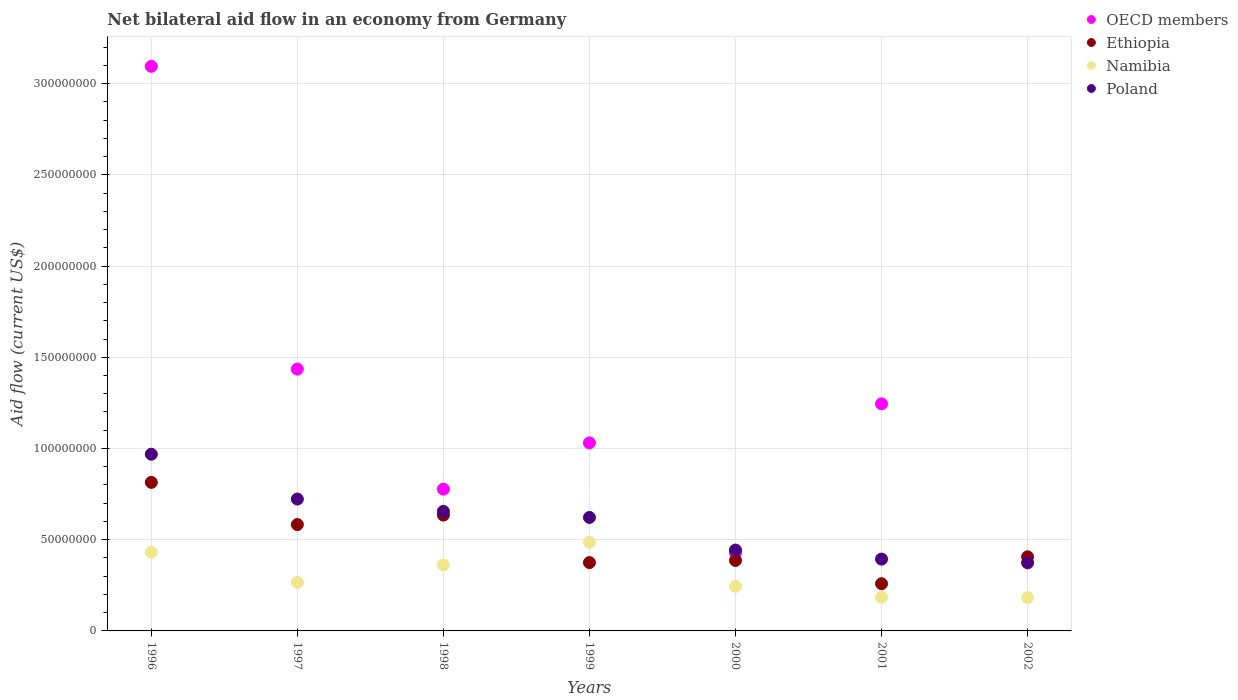What is the net bilateral aid flow in OECD members in 1998?
Your answer should be very brief. 7.77e+07. Across all years, what is the maximum net bilateral aid flow in Namibia?
Your answer should be compact. 4.85e+07. Across all years, what is the minimum net bilateral aid flow in Poland?
Keep it short and to the point. 3.73e+07. What is the total net bilateral aid flow in Ethiopia in the graph?
Provide a short and direct response. 3.46e+08. What is the difference between the net bilateral aid flow in Poland in 1998 and that in 1999?
Keep it short and to the point. 3.34e+06. What is the difference between the net bilateral aid flow in Ethiopia in 1998 and the net bilateral aid flow in Namibia in 1997?
Provide a short and direct response. 3.69e+07. What is the average net bilateral aid flow in Namibia per year?
Give a very brief answer. 3.08e+07. In the year 1999, what is the difference between the net bilateral aid flow in Poland and net bilateral aid flow in Namibia?
Your response must be concise. 1.37e+07. In how many years, is the net bilateral aid flow in OECD members greater than 230000000 US$?
Ensure brevity in your answer.  1. What is the ratio of the net bilateral aid flow in Ethiopia in 1998 to that in 1999?
Give a very brief answer. 1.69. Is the net bilateral aid flow in OECD members in 2000 less than that in 2001?
Make the answer very short. Yes. Is the difference between the net bilateral aid flow in Poland in 2000 and 2001 greater than the difference between the net bilateral aid flow in Namibia in 2000 and 2001?
Make the answer very short. No. What is the difference between the highest and the second highest net bilateral aid flow in Poland?
Offer a very short reply. 2.46e+07. What is the difference between the highest and the lowest net bilateral aid flow in OECD members?
Your response must be concise. 3.09e+08. In how many years, is the net bilateral aid flow in Poland greater than the average net bilateral aid flow in Poland taken over all years?
Keep it short and to the point. 4. Is the sum of the net bilateral aid flow in Namibia in 1999 and 2000 greater than the maximum net bilateral aid flow in Poland across all years?
Your answer should be very brief. No. Is it the case that in every year, the sum of the net bilateral aid flow in Ethiopia and net bilateral aid flow in OECD members  is greater than the net bilateral aid flow in Poland?
Ensure brevity in your answer.  Yes. Does the net bilateral aid flow in Ethiopia monotonically increase over the years?
Offer a very short reply. No. Is the net bilateral aid flow in OECD members strictly greater than the net bilateral aid flow in Poland over the years?
Your answer should be compact. No. How many years are there in the graph?
Offer a terse response. 7. Where does the legend appear in the graph?
Your answer should be very brief. Top right. How many legend labels are there?
Offer a terse response. 4. How are the legend labels stacked?
Your answer should be very brief. Vertical. What is the title of the graph?
Offer a terse response. Net bilateral aid flow in an economy from Germany. What is the label or title of the X-axis?
Your response must be concise. Years. What is the label or title of the Y-axis?
Offer a terse response. Aid flow (current US$). What is the Aid flow (current US$) in OECD members in 1996?
Your response must be concise. 3.09e+08. What is the Aid flow (current US$) of Ethiopia in 1996?
Provide a succinct answer. 8.14e+07. What is the Aid flow (current US$) of Namibia in 1996?
Provide a succinct answer. 4.31e+07. What is the Aid flow (current US$) in Poland in 1996?
Your response must be concise. 9.69e+07. What is the Aid flow (current US$) in OECD members in 1997?
Offer a very short reply. 1.44e+08. What is the Aid flow (current US$) of Ethiopia in 1997?
Offer a terse response. 5.83e+07. What is the Aid flow (current US$) in Namibia in 1997?
Offer a terse response. 2.66e+07. What is the Aid flow (current US$) in Poland in 1997?
Offer a very short reply. 7.23e+07. What is the Aid flow (current US$) of OECD members in 1998?
Offer a terse response. 7.77e+07. What is the Aid flow (current US$) of Ethiopia in 1998?
Keep it short and to the point. 6.35e+07. What is the Aid flow (current US$) in Namibia in 1998?
Offer a very short reply. 3.61e+07. What is the Aid flow (current US$) of Poland in 1998?
Your response must be concise. 6.55e+07. What is the Aid flow (current US$) in OECD members in 1999?
Provide a succinct answer. 1.03e+08. What is the Aid flow (current US$) of Ethiopia in 1999?
Keep it short and to the point. 3.75e+07. What is the Aid flow (current US$) of Namibia in 1999?
Offer a very short reply. 4.85e+07. What is the Aid flow (current US$) in Poland in 1999?
Your answer should be very brief. 6.22e+07. What is the Aid flow (current US$) in OECD members in 2000?
Offer a terse response. 4.28e+07. What is the Aid flow (current US$) in Ethiopia in 2000?
Offer a very short reply. 3.86e+07. What is the Aid flow (current US$) in Namibia in 2000?
Give a very brief answer. 2.44e+07. What is the Aid flow (current US$) in Poland in 2000?
Offer a terse response. 4.43e+07. What is the Aid flow (current US$) of OECD members in 2001?
Give a very brief answer. 1.24e+08. What is the Aid flow (current US$) of Ethiopia in 2001?
Your answer should be compact. 2.59e+07. What is the Aid flow (current US$) in Namibia in 2001?
Your answer should be very brief. 1.84e+07. What is the Aid flow (current US$) of Poland in 2001?
Offer a very short reply. 3.94e+07. What is the Aid flow (current US$) of Ethiopia in 2002?
Your response must be concise. 4.06e+07. What is the Aid flow (current US$) in Namibia in 2002?
Your answer should be compact. 1.83e+07. What is the Aid flow (current US$) in Poland in 2002?
Offer a very short reply. 3.73e+07. Across all years, what is the maximum Aid flow (current US$) of OECD members?
Provide a short and direct response. 3.09e+08. Across all years, what is the maximum Aid flow (current US$) in Ethiopia?
Provide a short and direct response. 8.14e+07. Across all years, what is the maximum Aid flow (current US$) in Namibia?
Your answer should be compact. 4.85e+07. Across all years, what is the maximum Aid flow (current US$) of Poland?
Your response must be concise. 9.69e+07. Across all years, what is the minimum Aid flow (current US$) of Ethiopia?
Your answer should be compact. 2.59e+07. Across all years, what is the minimum Aid flow (current US$) in Namibia?
Keep it short and to the point. 1.83e+07. Across all years, what is the minimum Aid flow (current US$) in Poland?
Offer a terse response. 3.73e+07. What is the total Aid flow (current US$) in OECD members in the graph?
Your response must be concise. 8.01e+08. What is the total Aid flow (current US$) of Ethiopia in the graph?
Keep it short and to the point. 3.46e+08. What is the total Aid flow (current US$) in Namibia in the graph?
Give a very brief answer. 2.15e+08. What is the total Aid flow (current US$) in Poland in the graph?
Provide a short and direct response. 4.18e+08. What is the difference between the Aid flow (current US$) in OECD members in 1996 and that in 1997?
Your response must be concise. 1.66e+08. What is the difference between the Aid flow (current US$) of Ethiopia in 1996 and that in 1997?
Make the answer very short. 2.31e+07. What is the difference between the Aid flow (current US$) of Namibia in 1996 and that in 1997?
Provide a short and direct response. 1.66e+07. What is the difference between the Aid flow (current US$) in Poland in 1996 and that in 1997?
Ensure brevity in your answer.  2.46e+07. What is the difference between the Aid flow (current US$) of OECD members in 1996 and that in 1998?
Your response must be concise. 2.32e+08. What is the difference between the Aid flow (current US$) in Ethiopia in 1996 and that in 1998?
Ensure brevity in your answer.  1.79e+07. What is the difference between the Aid flow (current US$) of Namibia in 1996 and that in 1998?
Give a very brief answer. 6.99e+06. What is the difference between the Aid flow (current US$) in Poland in 1996 and that in 1998?
Give a very brief answer. 3.13e+07. What is the difference between the Aid flow (current US$) in OECD members in 1996 and that in 1999?
Provide a succinct answer. 2.06e+08. What is the difference between the Aid flow (current US$) in Ethiopia in 1996 and that in 1999?
Provide a short and direct response. 4.40e+07. What is the difference between the Aid flow (current US$) of Namibia in 1996 and that in 1999?
Provide a short and direct response. -5.41e+06. What is the difference between the Aid flow (current US$) of Poland in 1996 and that in 1999?
Keep it short and to the point. 3.47e+07. What is the difference between the Aid flow (current US$) of OECD members in 1996 and that in 2000?
Provide a short and direct response. 2.67e+08. What is the difference between the Aid flow (current US$) of Ethiopia in 1996 and that in 2000?
Offer a very short reply. 4.28e+07. What is the difference between the Aid flow (current US$) of Namibia in 1996 and that in 2000?
Keep it short and to the point. 1.87e+07. What is the difference between the Aid flow (current US$) of Poland in 1996 and that in 2000?
Give a very brief answer. 5.25e+07. What is the difference between the Aid flow (current US$) in OECD members in 1996 and that in 2001?
Provide a succinct answer. 1.85e+08. What is the difference between the Aid flow (current US$) in Ethiopia in 1996 and that in 2001?
Offer a very short reply. 5.56e+07. What is the difference between the Aid flow (current US$) in Namibia in 1996 and that in 2001?
Offer a terse response. 2.47e+07. What is the difference between the Aid flow (current US$) in Poland in 1996 and that in 2001?
Make the answer very short. 5.75e+07. What is the difference between the Aid flow (current US$) of Ethiopia in 1996 and that in 2002?
Provide a succinct answer. 4.08e+07. What is the difference between the Aid flow (current US$) in Namibia in 1996 and that in 2002?
Keep it short and to the point. 2.48e+07. What is the difference between the Aid flow (current US$) in Poland in 1996 and that in 2002?
Keep it short and to the point. 5.95e+07. What is the difference between the Aid flow (current US$) in OECD members in 1997 and that in 1998?
Offer a very short reply. 6.58e+07. What is the difference between the Aid flow (current US$) in Ethiopia in 1997 and that in 1998?
Your response must be concise. -5.19e+06. What is the difference between the Aid flow (current US$) in Namibia in 1997 and that in 1998?
Offer a terse response. -9.56e+06. What is the difference between the Aid flow (current US$) of Poland in 1997 and that in 1998?
Your answer should be compact. 6.74e+06. What is the difference between the Aid flow (current US$) of OECD members in 1997 and that in 1999?
Ensure brevity in your answer.  4.04e+07. What is the difference between the Aid flow (current US$) in Ethiopia in 1997 and that in 1999?
Provide a succinct answer. 2.08e+07. What is the difference between the Aid flow (current US$) of Namibia in 1997 and that in 1999?
Offer a terse response. -2.20e+07. What is the difference between the Aid flow (current US$) of Poland in 1997 and that in 1999?
Offer a terse response. 1.01e+07. What is the difference between the Aid flow (current US$) of OECD members in 1997 and that in 2000?
Make the answer very short. 1.01e+08. What is the difference between the Aid flow (current US$) of Ethiopia in 1997 and that in 2000?
Provide a succinct answer. 1.97e+07. What is the difference between the Aid flow (current US$) of Namibia in 1997 and that in 2000?
Your response must be concise. 2.12e+06. What is the difference between the Aid flow (current US$) in Poland in 1997 and that in 2000?
Your answer should be very brief. 2.80e+07. What is the difference between the Aid flow (current US$) of OECD members in 1997 and that in 2001?
Offer a terse response. 1.90e+07. What is the difference between the Aid flow (current US$) of Ethiopia in 1997 and that in 2001?
Provide a succinct answer. 3.24e+07. What is the difference between the Aid flow (current US$) of Namibia in 1997 and that in 2001?
Provide a succinct answer. 8.14e+06. What is the difference between the Aid flow (current US$) in Poland in 1997 and that in 2001?
Provide a short and direct response. 3.29e+07. What is the difference between the Aid flow (current US$) in Ethiopia in 1997 and that in 2002?
Ensure brevity in your answer.  1.77e+07. What is the difference between the Aid flow (current US$) in Namibia in 1997 and that in 2002?
Your answer should be very brief. 8.29e+06. What is the difference between the Aid flow (current US$) of Poland in 1997 and that in 2002?
Ensure brevity in your answer.  3.50e+07. What is the difference between the Aid flow (current US$) of OECD members in 1998 and that in 1999?
Ensure brevity in your answer.  -2.53e+07. What is the difference between the Aid flow (current US$) of Ethiopia in 1998 and that in 1999?
Provide a succinct answer. 2.60e+07. What is the difference between the Aid flow (current US$) in Namibia in 1998 and that in 1999?
Your answer should be very brief. -1.24e+07. What is the difference between the Aid flow (current US$) of Poland in 1998 and that in 1999?
Your answer should be very brief. 3.34e+06. What is the difference between the Aid flow (current US$) of OECD members in 1998 and that in 2000?
Your response must be concise. 3.49e+07. What is the difference between the Aid flow (current US$) of Ethiopia in 1998 and that in 2000?
Ensure brevity in your answer.  2.49e+07. What is the difference between the Aid flow (current US$) in Namibia in 1998 and that in 2000?
Your response must be concise. 1.17e+07. What is the difference between the Aid flow (current US$) in Poland in 1998 and that in 2000?
Offer a terse response. 2.12e+07. What is the difference between the Aid flow (current US$) in OECD members in 1998 and that in 2001?
Give a very brief answer. -4.67e+07. What is the difference between the Aid flow (current US$) in Ethiopia in 1998 and that in 2001?
Give a very brief answer. 3.76e+07. What is the difference between the Aid flow (current US$) of Namibia in 1998 and that in 2001?
Your answer should be very brief. 1.77e+07. What is the difference between the Aid flow (current US$) in Poland in 1998 and that in 2001?
Offer a very short reply. 2.62e+07. What is the difference between the Aid flow (current US$) in Ethiopia in 1998 and that in 2002?
Ensure brevity in your answer.  2.29e+07. What is the difference between the Aid flow (current US$) of Namibia in 1998 and that in 2002?
Your answer should be very brief. 1.78e+07. What is the difference between the Aid flow (current US$) in Poland in 1998 and that in 2002?
Give a very brief answer. 2.82e+07. What is the difference between the Aid flow (current US$) in OECD members in 1999 and that in 2000?
Make the answer very short. 6.03e+07. What is the difference between the Aid flow (current US$) in Ethiopia in 1999 and that in 2000?
Provide a short and direct response. -1.17e+06. What is the difference between the Aid flow (current US$) of Namibia in 1999 and that in 2000?
Your answer should be very brief. 2.41e+07. What is the difference between the Aid flow (current US$) in Poland in 1999 and that in 2000?
Ensure brevity in your answer.  1.79e+07. What is the difference between the Aid flow (current US$) of OECD members in 1999 and that in 2001?
Give a very brief answer. -2.14e+07. What is the difference between the Aid flow (current US$) of Ethiopia in 1999 and that in 2001?
Provide a short and direct response. 1.16e+07. What is the difference between the Aid flow (current US$) of Namibia in 1999 and that in 2001?
Your answer should be compact. 3.01e+07. What is the difference between the Aid flow (current US$) of Poland in 1999 and that in 2001?
Keep it short and to the point. 2.28e+07. What is the difference between the Aid flow (current US$) of Ethiopia in 1999 and that in 2002?
Your response must be concise. -3.15e+06. What is the difference between the Aid flow (current US$) of Namibia in 1999 and that in 2002?
Keep it short and to the point. 3.02e+07. What is the difference between the Aid flow (current US$) of Poland in 1999 and that in 2002?
Offer a very short reply. 2.49e+07. What is the difference between the Aid flow (current US$) in OECD members in 2000 and that in 2001?
Provide a short and direct response. -8.17e+07. What is the difference between the Aid flow (current US$) in Ethiopia in 2000 and that in 2001?
Offer a terse response. 1.28e+07. What is the difference between the Aid flow (current US$) in Namibia in 2000 and that in 2001?
Offer a very short reply. 6.02e+06. What is the difference between the Aid flow (current US$) in Poland in 2000 and that in 2001?
Give a very brief answer. 4.95e+06. What is the difference between the Aid flow (current US$) in Ethiopia in 2000 and that in 2002?
Your response must be concise. -1.98e+06. What is the difference between the Aid flow (current US$) in Namibia in 2000 and that in 2002?
Provide a succinct answer. 6.17e+06. What is the difference between the Aid flow (current US$) of Poland in 2000 and that in 2002?
Make the answer very short. 6.99e+06. What is the difference between the Aid flow (current US$) in Ethiopia in 2001 and that in 2002?
Offer a very short reply. -1.47e+07. What is the difference between the Aid flow (current US$) of Poland in 2001 and that in 2002?
Offer a terse response. 2.04e+06. What is the difference between the Aid flow (current US$) of OECD members in 1996 and the Aid flow (current US$) of Ethiopia in 1997?
Give a very brief answer. 2.51e+08. What is the difference between the Aid flow (current US$) in OECD members in 1996 and the Aid flow (current US$) in Namibia in 1997?
Your answer should be very brief. 2.83e+08. What is the difference between the Aid flow (current US$) of OECD members in 1996 and the Aid flow (current US$) of Poland in 1997?
Make the answer very short. 2.37e+08. What is the difference between the Aid flow (current US$) in Ethiopia in 1996 and the Aid flow (current US$) in Namibia in 1997?
Offer a very short reply. 5.49e+07. What is the difference between the Aid flow (current US$) of Ethiopia in 1996 and the Aid flow (current US$) of Poland in 1997?
Ensure brevity in your answer.  9.15e+06. What is the difference between the Aid flow (current US$) of Namibia in 1996 and the Aid flow (current US$) of Poland in 1997?
Offer a terse response. -2.92e+07. What is the difference between the Aid flow (current US$) in OECD members in 1996 and the Aid flow (current US$) in Ethiopia in 1998?
Offer a terse response. 2.46e+08. What is the difference between the Aid flow (current US$) in OECD members in 1996 and the Aid flow (current US$) in Namibia in 1998?
Keep it short and to the point. 2.73e+08. What is the difference between the Aid flow (current US$) of OECD members in 1996 and the Aid flow (current US$) of Poland in 1998?
Ensure brevity in your answer.  2.44e+08. What is the difference between the Aid flow (current US$) of Ethiopia in 1996 and the Aid flow (current US$) of Namibia in 1998?
Make the answer very short. 4.53e+07. What is the difference between the Aid flow (current US$) in Ethiopia in 1996 and the Aid flow (current US$) in Poland in 1998?
Your answer should be compact. 1.59e+07. What is the difference between the Aid flow (current US$) in Namibia in 1996 and the Aid flow (current US$) in Poland in 1998?
Your response must be concise. -2.24e+07. What is the difference between the Aid flow (current US$) of OECD members in 1996 and the Aid flow (current US$) of Ethiopia in 1999?
Offer a very short reply. 2.72e+08. What is the difference between the Aid flow (current US$) of OECD members in 1996 and the Aid flow (current US$) of Namibia in 1999?
Make the answer very short. 2.61e+08. What is the difference between the Aid flow (current US$) in OECD members in 1996 and the Aid flow (current US$) in Poland in 1999?
Your answer should be very brief. 2.47e+08. What is the difference between the Aid flow (current US$) in Ethiopia in 1996 and the Aid flow (current US$) in Namibia in 1999?
Offer a very short reply. 3.29e+07. What is the difference between the Aid flow (current US$) in Ethiopia in 1996 and the Aid flow (current US$) in Poland in 1999?
Your answer should be very brief. 1.92e+07. What is the difference between the Aid flow (current US$) in Namibia in 1996 and the Aid flow (current US$) in Poland in 1999?
Offer a terse response. -1.91e+07. What is the difference between the Aid flow (current US$) in OECD members in 1996 and the Aid flow (current US$) in Ethiopia in 2000?
Your answer should be compact. 2.71e+08. What is the difference between the Aid flow (current US$) in OECD members in 1996 and the Aid flow (current US$) in Namibia in 2000?
Give a very brief answer. 2.85e+08. What is the difference between the Aid flow (current US$) in OECD members in 1996 and the Aid flow (current US$) in Poland in 2000?
Give a very brief answer. 2.65e+08. What is the difference between the Aid flow (current US$) of Ethiopia in 1996 and the Aid flow (current US$) of Namibia in 2000?
Your response must be concise. 5.70e+07. What is the difference between the Aid flow (current US$) of Ethiopia in 1996 and the Aid flow (current US$) of Poland in 2000?
Provide a short and direct response. 3.71e+07. What is the difference between the Aid flow (current US$) of Namibia in 1996 and the Aid flow (current US$) of Poland in 2000?
Your answer should be compact. -1.22e+06. What is the difference between the Aid flow (current US$) in OECD members in 1996 and the Aid flow (current US$) in Ethiopia in 2001?
Give a very brief answer. 2.84e+08. What is the difference between the Aid flow (current US$) in OECD members in 1996 and the Aid flow (current US$) in Namibia in 2001?
Your answer should be compact. 2.91e+08. What is the difference between the Aid flow (current US$) of OECD members in 1996 and the Aid flow (current US$) of Poland in 2001?
Your answer should be very brief. 2.70e+08. What is the difference between the Aid flow (current US$) of Ethiopia in 1996 and the Aid flow (current US$) of Namibia in 2001?
Your response must be concise. 6.30e+07. What is the difference between the Aid flow (current US$) of Ethiopia in 1996 and the Aid flow (current US$) of Poland in 2001?
Offer a very short reply. 4.21e+07. What is the difference between the Aid flow (current US$) of Namibia in 1996 and the Aid flow (current US$) of Poland in 2001?
Offer a very short reply. 3.73e+06. What is the difference between the Aid flow (current US$) of OECD members in 1996 and the Aid flow (current US$) of Ethiopia in 2002?
Offer a very short reply. 2.69e+08. What is the difference between the Aid flow (current US$) in OECD members in 1996 and the Aid flow (current US$) in Namibia in 2002?
Keep it short and to the point. 2.91e+08. What is the difference between the Aid flow (current US$) of OECD members in 1996 and the Aid flow (current US$) of Poland in 2002?
Keep it short and to the point. 2.72e+08. What is the difference between the Aid flow (current US$) in Ethiopia in 1996 and the Aid flow (current US$) in Namibia in 2002?
Offer a terse response. 6.32e+07. What is the difference between the Aid flow (current US$) in Ethiopia in 1996 and the Aid flow (current US$) in Poland in 2002?
Your answer should be very brief. 4.41e+07. What is the difference between the Aid flow (current US$) in Namibia in 1996 and the Aid flow (current US$) in Poland in 2002?
Keep it short and to the point. 5.77e+06. What is the difference between the Aid flow (current US$) of OECD members in 1997 and the Aid flow (current US$) of Ethiopia in 1998?
Make the answer very short. 8.00e+07. What is the difference between the Aid flow (current US$) of OECD members in 1997 and the Aid flow (current US$) of Namibia in 1998?
Provide a succinct answer. 1.07e+08. What is the difference between the Aid flow (current US$) in OECD members in 1997 and the Aid flow (current US$) in Poland in 1998?
Make the answer very short. 7.80e+07. What is the difference between the Aid flow (current US$) in Ethiopia in 1997 and the Aid flow (current US$) in Namibia in 1998?
Give a very brief answer. 2.22e+07. What is the difference between the Aid flow (current US$) of Ethiopia in 1997 and the Aid flow (current US$) of Poland in 1998?
Offer a terse response. -7.24e+06. What is the difference between the Aid flow (current US$) in Namibia in 1997 and the Aid flow (current US$) in Poland in 1998?
Make the answer very short. -3.90e+07. What is the difference between the Aid flow (current US$) in OECD members in 1997 and the Aid flow (current US$) in Ethiopia in 1999?
Your answer should be very brief. 1.06e+08. What is the difference between the Aid flow (current US$) of OECD members in 1997 and the Aid flow (current US$) of Namibia in 1999?
Give a very brief answer. 9.50e+07. What is the difference between the Aid flow (current US$) of OECD members in 1997 and the Aid flow (current US$) of Poland in 1999?
Keep it short and to the point. 8.13e+07. What is the difference between the Aid flow (current US$) of Ethiopia in 1997 and the Aid flow (current US$) of Namibia in 1999?
Provide a succinct answer. 9.79e+06. What is the difference between the Aid flow (current US$) of Ethiopia in 1997 and the Aid flow (current US$) of Poland in 1999?
Offer a terse response. -3.90e+06. What is the difference between the Aid flow (current US$) in Namibia in 1997 and the Aid flow (current US$) in Poland in 1999?
Offer a terse response. -3.56e+07. What is the difference between the Aid flow (current US$) of OECD members in 1997 and the Aid flow (current US$) of Ethiopia in 2000?
Offer a very short reply. 1.05e+08. What is the difference between the Aid flow (current US$) of OECD members in 1997 and the Aid flow (current US$) of Namibia in 2000?
Provide a succinct answer. 1.19e+08. What is the difference between the Aid flow (current US$) in OECD members in 1997 and the Aid flow (current US$) in Poland in 2000?
Offer a terse response. 9.92e+07. What is the difference between the Aid flow (current US$) in Ethiopia in 1997 and the Aid flow (current US$) in Namibia in 2000?
Your response must be concise. 3.39e+07. What is the difference between the Aid flow (current US$) in Ethiopia in 1997 and the Aid flow (current US$) in Poland in 2000?
Offer a very short reply. 1.40e+07. What is the difference between the Aid flow (current US$) in Namibia in 1997 and the Aid flow (current US$) in Poland in 2000?
Your answer should be compact. -1.78e+07. What is the difference between the Aid flow (current US$) of OECD members in 1997 and the Aid flow (current US$) of Ethiopia in 2001?
Make the answer very short. 1.18e+08. What is the difference between the Aid flow (current US$) in OECD members in 1997 and the Aid flow (current US$) in Namibia in 2001?
Your answer should be very brief. 1.25e+08. What is the difference between the Aid flow (current US$) in OECD members in 1997 and the Aid flow (current US$) in Poland in 2001?
Give a very brief answer. 1.04e+08. What is the difference between the Aid flow (current US$) of Ethiopia in 1997 and the Aid flow (current US$) of Namibia in 2001?
Keep it short and to the point. 3.99e+07. What is the difference between the Aid flow (current US$) in Ethiopia in 1997 and the Aid flow (current US$) in Poland in 2001?
Give a very brief answer. 1.89e+07. What is the difference between the Aid flow (current US$) of Namibia in 1997 and the Aid flow (current US$) of Poland in 2001?
Ensure brevity in your answer.  -1.28e+07. What is the difference between the Aid flow (current US$) of OECD members in 1997 and the Aid flow (current US$) of Ethiopia in 2002?
Offer a terse response. 1.03e+08. What is the difference between the Aid flow (current US$) of OECD members in 1997 and the Aid flow (current US$) of Namibia in 2002?
Your response must be concise. 1.25e+08. What is the difference between the Aid flow (current US$) in OECD members in 1997 and the Aid flow (current US$) in Poland in 2002?
Provide a succinct answer. 1.06e+08. What is the difference between the Aid flow (current US$) in Ethiopia in 1997 and the Aid flow (current US$) in Namibia in 2002?
Your response must be concise. 4.00e+07. What is the difference between the Aid flow (current US$) of Ethiopia in 1997 and the Aid flow (current US$) of Poland in 2002?
Ensure brevity in your answer.  2.10e+07. What is the difference between the Aid flow (current US$) in Namibia in 1997 and the Aid flow (current US$) in Poland in 2002?
Keep it short and to the point. -1.08e+07. What is the difference between the Aid flow (current US$) of OECD members in 1998 and the Aid flow (current US$) of Ethiopia in 1999?
Give a very brief answer. 4.03e+07. What is the difference between the Aid flow (current US$) in OECD members in 1998 and the Aid flow (current US$) in Namibia in 1999?
Your answer should be compact. 2.92e+07. What is the difference between the Aid flow (current US$) in OECD members in 1998 and the Aid flow (current US$) in Poland in 1999?
Keep it short and to the point. 1.55e+07. What is the difference between the Aid flow (current US$) of Ethiopia in 1998 and the Aid flow (current US$) of Namibia in 1999?
Provide a succinct answer. 1.50e+07. What is the difference between the Aid flow (current US$) of Ethiopia in 1998 and the Aid flow (current US$) of Poland in 1999?
Ensure brevity in your answer.  1.29e+06. What is the difference between the Aid flow (current US$) of Namibia in 1998 and the Aid flow (current US$) of Poland in 1999?
Make the answer very short. -2.61e+07. What is the difference between the Aid flow (current US$) in OECD members in 1998 and the Aid flow (current US$) in Ethiopia in 2000?
Your answer should be very brief. 3.91e+07. What is the difference between the Aid flow (current US$) in OECD members in 1998 and the Aid flow (current US$) in Namibia in 2000?
Provide a short and direct response. 5.33e+07. What is the difference between the Aid flow (current US$) of OECD members in 1998 and the Aid flow (current US$) of Poland in 2000?
Provide a succinct answer. 3.34e+07. What is the difference between the Aid flow (current US$) of Ethiopia in 1998 and the Aid flow (current US$) of Namibia in 2000?
Your answer should be compact. 3.91e+07. What is the difference between the Aid flow (current US$) of Ethiopia in 1998 and the Aid flow (current US$) of Poland in 2000?
Provide a short and direct response. 1.92e+07. What is the difference between the Aid flow (current US$) in Namibia in 1998 and the Aid flow (current US$) in Poland in 2000?
Provide a succinct answer. -8.21e+06. What is the difference between the Aid flow (current US$) of OECD members in 1998 and the Aid flow (current US$) of Ethiopia in 2001?
Your answer should be compact. 5.18e+07. What is the difference between the Aid flow (current US$) of OECD members in 1998 and the Aid flow (current US$) of Namibia in 2001?
Offer a terse response. 5.93e+07. What is the difference between the Aid flow (current US$) of OECD members in 1998 and the Aid flow (current US$) of Poland in 2001?
Offer a terse response. 3.84e+07. What is the difference between the Aid flow (current US$) in Ethiopia in 1998 and the Aid flow (current US$) in Namibia in 2001?
Your answer should be compact. 4.51e+07. What is the difference between the Aid flow (current US$) in Ethiopia in 1998 and the Aid flow (current US$) in Poland in 2001?
Provide a short and direct response. 2.41e+07. What is the difference between the Aid flow (current US$) in Namibia in 1998 and the Aid flow (current US$) in Poland in 2001?
Your answer should be very brief. -3.26e+06. What is the difference between the Aid flow (current US$) in OECD members in 1998 and the Aid flow (current US$) in Ethiopia in 2002?
Provide a short and direct response. 3.71e+07. What is the difference between the Aid flow (current US$) of OECD members in 1998 and the Aid flow (current US$) of Namibia in 2002?
Give a very brief answer. 5.95e+07. What is the difference between the Aid flow (current US$) of OECD members in 1998 and the Aid flow (current US$) of Poland in 2002?
Make the answer very short. 4.04e+07. What is the difference between the Aid flow (current US$) of Ethiopia in 1998 and the Aid flow (current US$) of Namibia in 2002?
Provide a short and direct response. 4.52e+07. What is the difference between the Aid flow (current US$) in Ethiopia in 1998 and the Aid flow (current US$) in Poland in 2002?
Give a very brief answer. 2.62e+07. What is the difference between the Aid flow (current US$) in Namibia in 1998 and the Aid flow (current US$) in Poland in 2002?
Make the answer very short. -1.22e+06. What is the difference between the Aid flow (current US$) of OECD members in 1999 and the Aid flow (current US$) of Ethiopia in 2000?
Keep it short and to the point. 6.44e+07. What is the difference between the Aid flow (current US$) of OECD members in 1999 and the Aid flow (current US$) of Namibia in 2000?
Your response must be concise. 7.86e+07. What is the difference between the Aid flow (current US$) in OECD members in 1999 and the Aid flow (current US$) in Poland in 2000?
Your response must be concise. 5.87e+07. What is the difference between the Aid flow (current US$) in Ethiopia in 1999 and the Aid flow (current US$) in Namibia in 2000?
Provide a succinct answer. 1.30e+07. What is the difference between the Aid flow (current US$) in Ethiopia in 1999 and the Aid flow (current US$) in Poland in 2000?
Your answer should be very brief. -6.86e+06. What is the difference between the Aid flow (current US$) in Namibia in 1999 and the Aid flow (current US$) in Poland in 2000?
Ensure brevity in your answer.  4.19e+06. What is the difference between the Aid flow (current US$) of OECD members in 1999 and the Aid flow (current US$) of Ethiopia in 2001?
Make the answer very short. 7.72e+07. What is the difference between the Aid flow (current US$) in OECD members in 1999 and the Aid flow (current US$) in Namibia in 2001?
Offer a very short reply. 8.46e+07. What is the difference between the Aid flow (current US$) in OECD members in 1999 and the Aid flow (current US$) in Poland in 2001?
Your response must be concise. 6.37e+07. What is the difference between the Aid flow (current US$) of Ethiopia in 1999 and the Aid flow (current US$) of Namibia in 2001?
Your answer should be very brief. 1.90e+07. What is the difference between the Aid flow (current US$) in Ethiopia in 1999 and the Aid flow (current US$) in Poland in 2001?
Provide a short and direct response. -1.91e+06. What is the difference between the Aid flow (current US$) in Namibia in 1999 and the Aid flow (current US$) in Poland in 2001?
Your answer should be very brief. 9.14e+06. What is the difference between the Aid flow (current US$) in OECD members in 1999 and the Aid flow (current US$) in Ethiopia in 2002?
Give a very brief answer. 6.24e+07. What is the difference between the Aid flow (current US$) in OECD members in 1999 and the Aid flow (current US$) in Namibia in 2002?
Offer a terse response. 8.48e+07. What is the difference between the Aid flow (current US$) of OECD members in 1999 and the Aid flow (current US$) of Poland in 2002?
Give a very brief answer. 6.57e+07. What is the difference between the Aid flow (current US$) of Ethiopia in 1999 and the Aid flow (current US$) of Namibia in 2002?
Provide a short and direct response. 1.92e+07. What is the difference between the Aid flow (current US$) of Namibia in 1999 and the Aid flow (current US$) of Poland in 2002?
Give a very brief answer. 1.12e+07. What is the difference between the Aid flow (current US$) of OECD members in 2000 and the Aid flow (current US$) of Ethiopia in 2001?
Your response must be concise. 1.69e+07. What is the difference between the Aid flow (current US$) in OECD members in 2000 and the Aid flow (current US$) in Namibia in 2001?
Your response must be concise. 2.44e+07. What is the difference between the Aid flow (current US$) of OECD members in 2000 and the Aid flow (current US$) of Poland in 2001?
Provide a short and direct response. 3.42e+06. What is the difference between the Aid flow (current US$) in Ethiopia in 2000 and the Aid flow (current US$) in Namibia in 2001?
Provide a short and direct response. 2.02e+07. What is the difference between the Aid flow (current US$) in Ethiopia in 2000 and the Aid flow (current US$) in Poland in 2001?
Offer a very short reply. -7.40e+05. What is the difference between the Aid flow (current US$) in Namibia in 2000 and the Aid flow (current US$) in Poland in 2001?
Keep it short and to the point. -1.49e+07. What is the difference between the Aid flow (current US$) in OECD members in 2000 and the Aid flow (current US$) in Ethiopia in 2002?
Your answer should be very brief. 2.18e+06. What is the difference between the Aid flow (current US$) of OECD members in 2000 and the Aid flow (current US$) of Namibia in 2002?
Offer a very short reply. 2.45e+07. What is the difference between the Aid flow (current US$) in OECD members in 2000 and the Aid flow (current US$) in Poland in 2002?
Provide a succinct answer. 5.46e+06. What is the difference between the Aid flow (current US$) of Ethiopia in 2000 and the Aid flow (current US$) of Namibia in 2002?
Your answer should be compact. 2.04e+07. What is the difference between the Aid flow (current US$) in Ethiopia in 2000 and the Aid flow (current US$) in Poland in 2002?
Offer a very short reply. 1.30e+06. What is the difference between the Aid flow (current US$) in Namibia in 2000 and the Aid flow (current US$) in Poland in 2002?
Provide a succinct answer. -1.29e+07. What is the difference between the Aid flow (current US$) of OECD members in 2001 and the Aid flow (current US$) of Ethiopia in 2002?
Your answer should be very brief. 8.39e+07. What is the difference between the Aid flow (current US$) of OECD members in 2001 and the Aid flow (current US$) of Namibia in 2002?
Make the answer very short. 1.06e+08. What is the difference between the Aid flow (current US$) in OECD members in 2001 and the Aid flow (current US$) in Poland in 2002?
Give a very brief answer. 8.71e+07. What is the difference between the Aid flow (current US$) of Ethiopia in 2001 and the Aid flow (current US$) of Namibia in 2002?
Provide a succinct answer. 7.62e+06. What is the difference between the Aid flow (current US$) of Ethiopia in 2001 and the Aid flow (current US$) of Poland in 2002?
Offer a very short reply. -1.14e+07. What is the difference between the Aid flow (current US$) in Namibia in 2001 and the Aid flow (current US$) in Poland in 2002?
Ensure brevity in your answer.  -1.89e+07. What is the average Aid flow (current US$) in OECD members per year?
Give a very brief answer. 1.14e+08. What is the average Aid flow (current US$) of Ethiopia per year?
Make the answer very short. 4.94e+07. What is the average Aid flow (current US$) of Namibia per year?
Ensure brevity in your answer.  3.08e+07. What is the average Aid flow (current US$) of Poland per year?
Offer a very short reply. 5.97e+07. In the year 1996, what is the difference between the Aid flow (current US$) of OECD members and Aid flow (current US$) of Ethiopia?
Give a very brief answer. 2.28e+08. In the year 1996, what is the difference between the Aid flow (current US$) of OECD members and Aid flow (current US$) of Namibia?
Your response must be concise. 2.66e+08. In the year 1996, what is the difference between the Aid flow (current US$) of OECD members and Aid flow (current US$) of Poland?
Ensure brevity in your answer.  2.13e+08. In the year 1996, what is the difference between the Aid flow (current US$) of Ethiopia and Aid flow (current US$) of Namibia?
Ensure brevity in your answer.  3.83e+07. In the year 1996, what is the difference between the Aid flow (current US$) of Ethiopia and Aid flow (current US$) of Poland?
Your answer should be compact. -1.54e+07. In the year 1996, what is the difference between the Aid flow (current US$) in Namibia and Aid flow (current US$) in Poland?
Offer a very short reply. -5.38e+07. In the year 1997, what is the difference between the Aid flow (current US$) in OECD members and Aid flow (current US$) in Ethiopia?
Offer a very short reply. 8.52e+07. In the year 1997, what is the difference between the Aid flow (current US$) in OECD members and Aid flow (current US$) in Namibia?
Give a very brief answer. 1.17e+08. In the year 1997, what is the difference between the Aid flow (current US$) of OECD members and Aid flow (current US$) of Poland?
Your answer should be very brief. 7.12e+07. In the year 1997, what is the difference between the Aid flow (current US$) in Ethiopia and Aid flow (current US$) in Namibia?
Provide a succinct answer. 3.18e+07. In the year 1997, what is the difference between the Aid flow (current US$) in Ethiopia and Aid flow (current US$) in Poland?
Offer a very short reply. -1.40e+07. In the year 1997, what is the difference between the Aid flow (current US$) of Namibia and Aid flow (current US$) of Poland?
Give a very brief answer. -4.57e+07. In the year 1998, what is the difference between the Aid flow (current US$) of OECD members and Aid flow (current US$) of Ethiopia?
Make the answer very short. 1.42e+07. In the year 1998, what is the difference between the Aid flow (current US$) in OECD members and Aid flow (current US$) in Namibia?
Provide a succinct answer. 4.16e+07. In the year 1998, what is the difference between the Aid flow (current US$) in OECD members and Aid flow (current US$) in Poland?
Give a very brief answer. 1.22e+07. In the year 1998, what is the difference between the Aid flow (current US$) of Ethiopia and Aid flow (current US$) of Namibia?
Your answer should be very brief. 2.74e+07. In the year 1998, what is the difference between the Aid flow (current US$) of Ethiopia and Aid flow (current US$) of Poland?
Provide a succinct answer. -2.05e+06. In the year 1998, what is the difference between the Aid flow (current US$) of Namibia and Aid flow (current US$) of Poland?
Your answer should be compact. -2.94e+07. In the year 1999, what is the difference between the Aid flow (current US$) in OECD members and Aid flow (current US$) in Ethiopia?
Offer a terse response. 6.56e+07. In the year 1999, what is the difference between the Aid flow (current US$) of OECD members and Aid flow (current US$) of Namibia?
Provide a short and direct response. 5.46e+07. In the year 1999, what is the difference between the Aid flow (current US$) in OECD members and Aid flow (current US$) in Poland?
Provide a short and direct response. 4.09e+07. In the year 1999, what is the difference between the Aid flow (current US$) in Ethiopia and Aid flow (current US$) in Namibia?
Your response must be concise. -1.10e+07. In the year 1999, what is the difference between the Aid flow (current US$) of Ethiopia and Aid flow (current US$) of Poland?
Your answer should be compact. -2.47e+07. In the year 1999, what is the difference between the Aid flow (current US$) in Namibia and Aid flow (current US$) in Poland?
Your answer should be very brief. -1.37e+07. In the year 2000, what is the difference between the Aid flow (current US$) of OECD members and Aid flow (current US$) of Ethiopia?
Offer a terse response. 4.16e+06. In the year 2000, what is the difference between the Aid flow (current US$) in OECD members and Aid flow (current US$) in Namibia?
Your response must be concise. 1.84e+07. In the year 2000, what is the difference between the Aid flow (current US$) in OECD members and Aid flow (current US$) in Poland?
Your response must be concise. -1.53e+06. In the year 2000, what is the difference between the Aid flow (current US$) of Ethiopia and Aid flow (current US$) of Namibia?
Provide a succinct answer. 1.42e+07. In the year 2000, what is the difference between the Aid flow (current US$) in Ethiopia and Aid flow (current US$) in Poland?
Offer a terse response. -5.69e+06. In the year 2000, what is the difference between the Aid flow (current US$) in Namibia and Aid flow (current US$) in Poland?
Provide a short and direct response. -1.99e+07. In the year 2001, what is the difference between the Aid flow (current US$) in OECD members and Aid flow (current US$) in Ethiopia?
Offer a very short reply. 9.86e+07. In the year 2001, what is the difference between the Aid flow (current US$) in OECD members and Aid flow (current US$) in Namibia?
Make the answer very short. 1.06e+08. In the year 2001, what is the difference between the Aid flow (current US$) of OECD members and Aid flow (current US$) of Poland?
Give a very brief answer. 8.51e+07. In the year 2001, what is the difference between the Aid flow (current US$) of Ethiopia and Aid flow (current US$) of Namibia?
Keep it short and to the point. 7.47e+06. In the year 2001, what is the difference between the Aid flow (current US$) in Ethiopia and Aid flow (current US$) in Poland?
Offer a very short reply. -1.35e+07. In the year 2001, what is the difference between the Aid flow (current US$) of Namibia and Aid flow (current US$) of Poland?
Your answer should be very brief. -2.10e+07. In the year 2002, what is the difference between the Aid flow (current US$) in Ethiopia and Aid flow (current US$) in Namibia?
Offer a terse response. 2.24e+07. In the year 2002, what is the difference between the Aid flow (current US$) of Ethiopia and Aid flow (current US$) of Poland?
Your answer should be very brief. 3.28e+06. In the year 2002, what is the difference between the Aid flow (current US$) of Namibia and Aid flow (current US$) of Poland?
Your answer should be very brief. -1.91e+07. What is the ratio of the Aid flow (current US$) of OECD members in 1996 to that in 1997?
Your answer should be very brief. 2.16. What is the ratio of the Aid flow (current US$) in Ethiopia in 1996 to that in 1997?
Your answer should be very brief. 1.4. What is the ratio of the Aid flow (current US$) of Namibia in 1996 to that in 1997?
Provide a short and direct response. 1.62. What is the ratio of the Aid flow (current US$) of Poland in 1996 to that in 1997?
Keep it short and to the point. 1.34. What is the ratio of the Aid flow (current US$) in OECD members in 1996 to that in 1998?
Give a very brief answer. 3.98. What is the ratio of the Aid flow (current US$) of Ethiopia in 1996 to that in 1998?
Give a very brief answer. 1.28. What is the ratio of the Aid flow (current US$) of Namibia in 1996 to that in 1998?
Your response must be concise. 1.19. What is the ratio of the Aid flow (current US$) of Poland in 1996 to that in 1998?
Offer a very short reply. 1.48. What is the ratio of the Aid flow (current US$) in OECD members in 1996 to that in 1999?
Your answer should be compact. 3. What is the ratio of the Aid flow (current US$) of Ethiopia in 1996 to that in 1999?
Give a very brief answer. 2.17. What is the ratio of the Aid flow (current US$) in Namibia in 1996 to that in 1999?
Give a very brief answer. 0.89. What is the ratio of the Aid flow (current US$) in Poland in 1996 to that in 1999?
Your answer should be very brief. 1.56. What is the ratio of the Aid flow (current US$) of OECD members in 1996 to that in 2000?
Keep it short and to the point. 7.23. What is the ratio of the Aid flow (current US$) in Ethiopia in 1996 to that in 2000?
Offer a terse response. 2.11. What is the ratio of the Aid flow (current US$) of Namibia in 1996 to that in 2000?
Keep it short and to the point. 1.76. What is the ratio of the Aid flow (current US$) in Poland in 1996 to that in 2000?
Provide a succinct answer. 2.19. What is the ratio of the Aid flow (current US$) in OECD members in 1996 to that in 2001?
Give a very brief answer. 2.49. What is the ratio of the Aid flow (current US$) in Ethiopia in 1996 to that in 2001?
Offer a very short reply. 3.15. What is the ratio of the Aid flow (current US$) of Namibia in 1996 to that in 2001?
Offer a very short reply. 2.34. What is the ratio of the Aid flow (current US$) of Poland in 1996 to that in 2001?
Ensure brevity in your answer.  2.46. What is the ratio of the Aid flow (current US$) in Ethiopia in 1996 to that in 2002?
Keep it short and to the point. 2.01. What is the ratio of the Aid flow (current US$) of Namibia in 1996 to that in 2002?
Keep it short and to the point. 2.36. What is the ratio of the Aid flow (current US$) of Poland in 1996 to that in 2002?
Keep it short and to the point. 2.59. What is the ratio of the Aid flow (current US$) in OECD members in 1997 to that in 1998?
Your answer should be compact. 1.85. What is the ratio of the Aid flow (current US$) of Ethiopia in 1997 to that in 1998?
Your answer should be compact. 0.92. What is the ratio of the Aid flow (current US$) of Namibia in 1997 to that in 1998?
Provide a short and direct response. 0.74. What is the ratio of the Aid flow (current US$) of Poland in 1997 to that in 1998?
Your answer should be compact. 1.1. What is the ratio of the Aid flow (current US$) of OECD members in 1997 to that in 1999?
Make the answer very short. 1.39. What is the ratio of the Aid flow (current US$) in Ethiopia in 1997 to that in 1999?
Provide a short and direct response. 1.56. What is the ratio of the Aid flow (current US$) of Namibia in 1997 to that in 1999?
Provide a short and direct response. 0.55. What is the ratio of the Aid flow (current US$) in Poland in 1997 to that in 1999?
Make the answer very short. 1.16. What is the ratio of the Aid flow (current US$) of OECD members in 1997 to that in 2000?
Give a very brief answer. 3.35. What is the ratio of the Aid flow (current US$) in Ethiopia in 1997 to that in 2000?
Your answer should be very brief. 1.51. What is the ratio of the Aid flow (current US$) in Namibia in 1997 to that in 2000?
Your answer should be very brief. 1.09. What is the ratio of the Aid flow (current US$) of Poland in 1997 to that in 2000?
Your answer should be very brief. 1.63. What is the ratio of the Aid flow (current US$) in OECD members in 1997 to that in 2001?
Provide a succinct answer. 1.15. What is the ratio of the Aid flow (current US$) in Ethiopia in 1997 to that in 2001?
Your answer should be very brief. 2.25. What is the ratio of the Aid flow (current US$) of Namibia in 1997 to that in 2001?
Offer a very short reply. 1.44. What is the ratio of the Aid flow (current US$) of Poland in 1997 to that in 2001?
Give a very brief answer. 1.84. What is the ratio of the Aid flow (current US$) in Ethiopia in 1997 to that in 2002?
Offer a terse response. 1.44. What is the ratio of the Aid flow (current US$) of Namibia in 1997 to that in 2002?
Your response must be concise. 1.45. What is the ratio of the Aid flow (current US$) in Poland in 1997 to that in 2002?
Give a very brief answer. 1.94. What is the ratio of the Aid flow (current US$) in OECD members in 1998 to that in 1999?
Ensure brevity in your answer.  0.75. What is the ratio of the Aid flow (current US$) of Ethiopia in 1998 to that in 1999?
Your answer should be compact. 1.69. What is the ratio of the Aid flow (current US$) of Namibia in 1998 to that in 1999?
Give a very brief answer. 0.74. What is the ratio of the Aid flow (current US$) of Poland in 1998 to that in 1999?
Provide a short and direct response. 1.05. What is the ratio of the Aid flow (current US$) of OECD members in 1998 to that in 2000?
Offer a terse response. 1.82. What is the ratio of the Aid flow (current US$) of Ethiopia in 1998 to that in 2000?
Your answer should be compact. 1.64. What is the ratio of the Aid flow (current US$) of Namibia in 1998 to that in 2000?
Offer a terse response. 1.48. What is the ratio of the Aid flow (current US$) of Poland in 1998 to that in 2000?
Ensure brevity in your answer.  1.48. What is the ratio of the Aid flow (current US$) in OECD members in 1998 to that in 2001?
Your response must be concise. 0.62. What is the ratio of the Aid flow (current US$) in Ethiopia in 1998 to that in 2001?
Provide a short and direct response. 2.45. What is the ratio of the Aid flow (current US$) of Namibia in 1998 to that in 2001?
Make the answer very short. 1.96. What is the ratio of the Aid flow (current US$) of Poland in 1998 to that in 2001?
Your response must be concise. 1.66. What is the ratio of the Aid flow (current US$) of Ethiopia in 1998 to that in 2002?
Provide a succinct answer. 1.56. What is the ratio of the Aid flow (current US$) of Namibia in 1998 to that in 2002?
Give a very brief answer. 1.98. What is the ratio of the Aid flow (current US$) in Poland in 1998 to that in 2002?
Provide a succinct answer. 1.76. What is the ratio of the Aid flow (current US$) of OECD members in 1999 to that in 2000?
Your answer should be very brief. 2.41. What is the ratio of the Aid flow (current US$) in Ethiopia in 1999 to that in 2000?
Provide a succinct answer. 0.97. What is the ratio of the Aid flow (current US$) of Namibia in 1999 to that in 2000?
Your response must be concise. 1.99. What is the ratio of the Aid flow (current US$) of Poland in 1999 to that in 2000?
Keep it short and to the point. 1.4. What is the ratio of the Aid flow (current US$) in OECD members in 1999 to that in 2001?
Keep it short and to the point. 0.83. What is the ratio of the Aid flow (current US$) in Ethiopia in 1999 to that in 2001?
Give a very brief answer. 1.45. What is the ratio of the Aid flow (current US$) in Namibia in 1999 to that in 2001?
Offer a terse response. 2.63. What is the ratio of the Aid flow (current US$) in Poland in 1999 to that in 2001?
Provide a short and direct response. 1.58. What is the ratio of the Aid flow (current US$) of Ethiopia in 1999 to that in 2002?
Provide a succinct answer. 0.92. What is the ratio of the Aid flow (current US$) in Namibia in 1999 to that in 2002?
Provide a short and direct response. 2.66. What is the ratio of the Aid flow (current US$) in Poland in 1999 to that in 2002?
Your answer should be compact. 1.67. What is the ratio of the Aid flow (current US$) in OECD members in 2000 to that in 2001?
Provide a succinct answer. 0.34. What is the ratio of the Aid flow (current US$) of Ethiopia in 2000 to that in 2001?
Your answer should be very brief. 1.49. What is the ratio of the Aid flow (current US$) in Namibia in 2000 to that in 2001?
Provide a succinct answer. 1.33. What is the ratio of the Aid flow (current US$) in Poland in 2000 to that in 2001?
Ensure brevity in your answer.  1.13. What is the ratio of the Aid flow (current US$) in Ethiopia in 2000 to that in 2002?
Your answer should be very brief. 0.95. What is the ratio of the Aid flow (current US$) in Namibia in 2000 to that in 2002?
Make the answer very short. 1.34. What is the ratio of the Aid flow (current US$) of Poland in 2000 to that in 2002?
Offer a very short reply. 1.19. What is the ratio of the Aid flow (current US$) of Ethiopia in 2001 to that in 2002?
Your answer should be very brief. 0.64. What is the ratio of the Aid flow (current US$) of Namibia in 2001 to that in 2002?
Give a very brief answer. 1.01. What is the ratio of the Aid flow (current US$) of Poland in 2001 to that in 2002?
Give a very brief answer. 1.05. What is the difference between the highest and the second highest Aid flow (current US$) in OECD members?
Ensure brevity in your answer.  1.66e+08. What is the difference between the highest and the second highest Aid flow (current US$) in Ethiopia?
Provide a short and direct response. 1.79e+07. What is the difference between the highest and the second highest Aid flow (current US$) of Namibia?
Your response must be concise. 5.41e+06. What is the difference between the highest and the second highest Aid flow (current US$) in Poland?
Offer a terse response. 2.46e+07. What is the difference between the highest and the lowest Aid flow (current US$) in OECD members?
Your answer should be very brief. 3.09e+08. What is the difference between the highest and the lowest Aid flow (current US$) of Ethiopia?
Offer a very short reply. 5.56e+07. What is the difference between the highest and the lowest Aid flow (current US$) of Namibia?
Your response must be concise. 3.02e+07. What is the difference between the highest and the lowest Aid flow (current US$) in Poland?
Make the answer very short. 5.95e+07. 